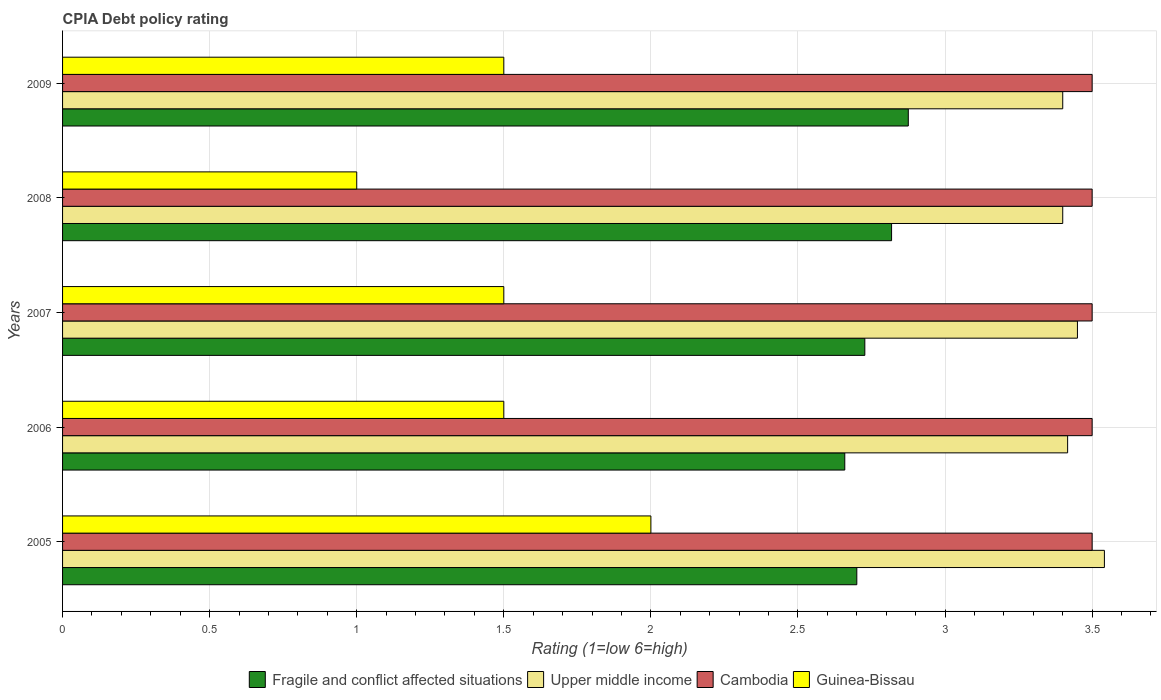How many groups of bars are there?
Offer a terse response. 5. Are the number of bars on each tick of the Y-axis equal?
Your answer should be very brief. Yes. What is the CPIA rating in Upper middle income in 2007?
Ensure brevity in your answer.  3.45. Across all years, what is the maximum CPIA rating in Cambodia?
Make the answer very short. 3.5. Across all years, what is the minimum CPIA rating in Cambodia?
Give a very brief answer. 3.5. In which year was the CPIA rating in Guinea-Bissau minimum?
Keep it short and to the point. 2008. What is the total CPIA rating in Guinea-Bissau in the graph?
Make the answer very short. 7.5. What is the difference between the CPIA rating in Cambodia in 2006 and that in 2007?
Ensure brevity in your answer.  0. What is the difference between the CPIA rating in Fragile and conflict affected situations in 2009 and the CPIA rating in Cambodia in 2008?
Your answer should be compact. -0.62. What is the average CPIA rating in Fragile and conflict affected situations per year?
Ensure brevity in your answer.  2.76. In the year 2005, what is the difference between the CPIA rating in Upper middle income and CPIA rating in Fragile and conflict affected situations?
Give a very brief answer. 0.84. What is the ratio of the CPIA rating in Upper middle income in 2006 to that in 2007?
Offer a very short reply. 0.99. Is the CPIA rating in Guinea-Bissau in 2005 less than that in 2007?
Your response must be concise. No. What is the difference between the highest and the second highest CPIA rating in Upper middle income?
Provide a succinct answer. 0.09. What is the difference between the highest and the lowest CPIA rating in Cambodia?
Provide a short and direct response. 0. In how many years, is the CPIA rating in Cambodia greater than the average CPIA rating in Cambodia taken over all years?
Your response must be concise. 0. Is it the case that in every year, the sum of the CPIA rating in Guinea-Bissau and CPIA rating in Upper middle income is greater than the sum of CPIA rating in Fragile and conflict affected situations and CPIA rating in Cambodia?
Keep it short and to the point. No. What does the 1st bar from the top in 2006 represents?
Your response must be concise. Guinea-Bissau. What does the 3rd bar from the bottom in 2008 represents?
Make the answer very short. Cambodia. Is it the case that in every year, the sum of the CPIA rating in Cambodia and CPIA rating in Guinea-Bissau is greater than the CPIA rating in Fragile and conflict affected situations?
Your answer should be very brief. Yes. How many bars are there?
Your answer should be very brief. 20. Does the graph contain any zero values?
Provide a short and direct response. No. Does the graph contain grids?
Keep it short and to the point. Yes. Where does the legend appear in the graph?
Your answer should be very brief. Bottom center. What is the title of the graph?
Provide a succinct answer. CPIA Debt policy rating. What is the label or title of the X-axis?
Your response must be concise. Rating (1=low 6=high). What is the label or title of the Y-axis?
Provide a short and direct response. Years. What is the Rating (1=low 6=high) in Upper middle income in 2005?
Offer a terse response. 3.54. What is the Rating (1=low 6=high) of Fragile and conflict affected situations in 2006?
Provide a short and direct response. 2.66. What is the Rating (1=low 6=high) in Upper middle income in 2006?
Offer a very short reply. 3.42. What is the Rating (1=low 6=high) of Guinea-Bissau in 2006?
Your answer should be very brief. 1.5. What is the Rating (1=low 6=high) of Fragile and conflict affected situations in 2007?
Your response must be concise. 2.73. What is the Rating (1=low 6=high) of Upper middle income in 2007?
Keep it short and to the point. 3.45. What is the Rating (1=low 6=high) of Cambodia in 2007?
Ensure brevity in your answer.  3.5. What is the Rating (1=low 6=high) of Fragile and conflict affected situations in 2008?
Ensure brevity in your answer.  2.82. What is the Rating (1=low 6=high) in Upper middle income in 2008?
Your answer should be very brief. 3.4. What is the Rating (1=low 6=high) in Cambodia in 2008?
Your response must be concise. 3.5. What is the Rating (1=low 6=high) of Fragile and conflict affected situations in 2009?
Offer a very short reply. 2.88. What is the Rating (1=low 6=high) in Cambodia in 2009?
Provide a succinct answer. 3.5. What is the Rating (1=low 6=high) of Guinea-Bissau in 2009?
Offer a very short reply. 1.5. Across all years, what is the maximum Rating (1=low 6=high) in Fragile and conflict affected situations?
Give a very brief answer. 2.88. Across all years, what is the maximum Rating (1=low 6=high) in Upper middle income?
Provide a succinct answer. 3.54. Across all years, what is the maximum Rating (1=low 6=high) of Guinea-Bissau?
Your response must be concise. 2. Across all years, what is the minimum Rating (1=low 6=high) of Fragile and conflict affected situations?
Make the answer very short. 2.66. Across all years, what is the minimum Rating (1=low 6=high) in Upper middle income?
Offer a very short reply. 3.4. What is the total Rating (1=low 6=high) of Fragile and conflict affected situations in the graph?
Your answer should be very brief. 13.78. What is the total Rating (1=low 6=high) of Upper middle income in the graph?
Offer a very short reply. 17.21. What is the total Rating (1=low 6=high) in Guinea-Bissau in the graph?
Provide a succinct answer. 7.5. What is the difference between the Rating (1=low 6=high) in Fragile and conflict affected situations in 2005 and that in 2006?
Offer a very short reply. 0.04. What is the difference between the Rating (1=low 6=high) of Upper middle income in 2005 and that in 2006?
Keep it short and to the point. 0.12. What is the difference between the Rating (1=low 6=high) of Guinea-Bissau in 2005 and that in 2006?
Provide a succinct answer. 0.5. What is the difference between the Rating (1=low 6=high) of Fragile and conflict affected situations in 2005 and that in 2007?
Provide a short and direct response. -0.03. What is the difference between the Rating (1=low 6=high) of Upper middle income in 2005 and that in 2007?
Make the answer very short. 0.09. What is the difference between the Rating (1=low 6=high) in Guinea-Bissau in 2005 and that in 2007?
Make the answer very short. 0.5. What is the difference between the Rating (1=low 6=high) in Fragile and conflict affected situations in 2005 and that in 2008?
Offer a terse response. -0.12. What is the difference between the Rating (1=low 6=high) in Upper middle income in 2005 and that in 2008?
Your response must be concise. 0.14. What is the difference between the Rating (1=low 6=high) in Cambodia in 2005 and that in 2008?
Keep it short and to the point. 0. What is the difference between the Rating (1=low 6=high) in Fragile and conflict affected situations in 2005 and that in 2009?
Offer a very short reply. -0.17. What is the difference between the Rating (1=low 6=high) in Upper middle income in 2005 and that in 2009?
Offer a terse response. 0.14. What is the difference between the Rating (1=low 6=high) of Fragile and conflict affected situations in 2006 and that in 2007?
Give a very brief answer. -0.07. What is the difference between the Rating (1=low 6=high) in Upper middle income in 2006 and that in 2007?
Your response must be concise. -0.03. What is the difference between the Rating (1=low 6=high) of Guinea-Bissau in 2006 and that in 2007?
Make the answer very short. 0. What is the difference between the Rating (1=low 6=high) of Fragile and conflict affected situations in 2006 and that in 2008?
Your answer should be very brief. -0.16. What is the difference between the Rating (1=low 6=high) of Upper middle income in 2006 and that in 2008?
Offer a terse response. 0.02. What is the difference between the Rating (1=low 6=high) of Guinea-Bissau in 2006 and that in 2008?
Your response must be concise. 0.5. What is the difference between the Rating (1=low 6=high) in Fragile and conflict affected situations in 2006 and that in 2009?
Provide a succinct answer. -0.22. What is the difference between the Rating (1=low 6=high) in Upper middle income in 2006 and that in 2009?
Provide a short and direct response. 0.02. What is the difference between the Rating (1=low 6=high) in Cambodia in 2006 and that in 2009?
Offer a very short reply. 0. What is the difference between the Rating (1=low 6=high) in Guinea-Bissau in 2006 and that in 2009?
Offer a very short reply. 0. What is the difference between the Rating (1=low 6=high) in Fragile and conflict affected situations in 2007 and that in 2008?
Offer a very short reply. -0.09. What is the difference between the Rating (1=low 6=high) in Upper middle income in 2007 and that in 2008?
Your answer should be compact. 0.05. What is the difference between the Rating (1=low 6=high) of Fragile and conflict affected situations in 2007 and that in 2009?
Give a very brief answer. -0.15. What is the difference between the Rating (1=low 6=high) of Cambodia in 2007 and that in 2009?
Your response must be concise. 0. What is the difference between the Rating (1=low 6=high) in Fragile and conflict affected situations in 2008 and that in 2009?
Offer a terse response. -0.06. What is the difference between the Rating (1=low 6=high) of Upper middle income in 2008 and that in 2009?
Provide a short and direct response. 0. What is the difference between the Rating (1=low 6=high) in Fragile and conflict affected situations in 2005 and the Rating (1=low 6=high) in Upper middle income in 2006?
Keep it short and to the point. -0.72. What is the difference between the Rating (1=low 6=high) of Fragile and conflict affected situations in 2005 and the Rating (1=low 6=high) of Cambodia in 2006?
Provide a short and direct response. -0.8. What is the difference between the Rating (1=low 6=high) of Fragile and conflict affected situations in 2005 and the Rating (1=low 6=high) of Guinea-Bissau in 2006?
Keep it short and to the point. 1.2. What is the difference between the Rating (1=low 6=high) in Upper middle income in 2005 and the Rating (1=low 6=high) in Cambodia in 2006?
Your answer should be very brief. 0.04. What is the difference between the Rating (1=low 6=high) of Upper middle income in 2005 and the Rating (1=low 6=high) of Guinea-Bissau in 2006?
Provide a succinct answer. 2.04. What is the difference between the Rating (1=low 6=high) in Fragile and conflict affected situations in 2005 and the Rating (1=low 6=high) in Upper middle income in 2007?
Offer a very short reply. -0.75. What is the difference between the Rating (1=low 6=high) of Fragile and conflict affected situations in 2005 and the Rating (1=low 6=high) of Cambodia in 2007?
Your answer should be compact. -0.8. What is the difference between the Rating (1=low 6=high) in Fragile and conflict affected situations in 2005 and the Rating (1=low 6=high) in Guinea-Bissau in 2007?
Offer a terse response. 1.2. What is the difference between the Rating (1=low 6=high) in Upper middle income in 2005 and the Rating (1=low 6=high) in Cambodia in 2007?
Provide a short and direct response. 0.04. What is the difference between the Rating (1=low 6=high) of Upper middle income in 2005 and the Rating (1=low 6=high) of Guinea-Bissau in 2007?
Keep it short and to the point. 2.04. What is the difference between the Rating (1=low 6=high) of Fragile and conflict affected situations in 2005 and the Rating (1=low 6=high) of Upper middle income in 2008?
Keep it short and to the point. -0.7. What is the difference between the Rating (1=low 6=high) of Upper middle income in 2005 and the Rating (1=low 6=high) of Cambodia in 2008?
Provide a succinct answer. 0.04. What is the difference between the Rating (1=low 6=high) in Upper middle income in 2005 and the Rating (1=low 6=high) in Guinea-Bissau in 2008?
Keep it short and to the point. 2.54. What is the difference between the Rating (1=low 6=high) of Fragile and conflict affected situations in 2005 and the Rating (1=low 6=high) of Cambodia in 2009?
Your answer should be very brief. -0.8. What is the difference between the Rating (1=low 6=high) in Upper middle income in 2005 and the Rating (1=low 6=high) in Cambodia in 2009?
Your answer should be very brief. 0.04. What is the difference between the Rating (1=low 6=high) in Upper middle income in 2005 and the Rating (1=low 6=high) in Guinea-Bissau in 2009?
Ensure brevity in your answer.  2.04. What is the difference between the Rating (1=low 6=high) in Cambodia in 2005 and the Rating (1=low 6=high) in Guinea-Bissau in 2009?
Offer a terse response. 2. What is the difference between the Rating (1=low 6=high) in Fragile and conflict affected situations in 2006 and the Rating (1=low 6=high) in Upper middle income in 2007?
Provide a short and direct response. -0.79. What is the difference between the Rating (1=low 6=high) in Fragile and conflict affected situations in 2006 and the Rating (1=low 6=high) in Cambodia in 2007?
Offer a terse response. -0.84. What is the difference between the Rating (1=low 6=high) in Fragile and conflict affected situations in 2006 and the Rating (1=low 6=high) in Guinea-Bissau in 2007?
Your answer should be compact. 1.16. What is the difference between the Rating (1=low 6=high) of Upper middle income in 2006 and the Rating (1=low 6=high) of Cambodia in 2007?
Your response must be concise. -0.08. What is the difference between the Rating (1=low 6=high) of Upper middle income in 2006 and the Rating (1=low 6=high) of Guinea-Bissau in 2007?
Make the answer very short. 1.92. What is the difference between the Rating (1=low 6=high) in Fragile and conflict affected situations in 2006 and the Rating (1=low 6=high) in Upper middle income in 2008?
Your response must be concise. -0.74. What is the difference between the Rating (1=low 6=high) in Fragile and conflict affected situations in 2006 and the Rating (1=low 6=high) in Cambodia in 2008?
Keep it short and to the point. -0.84. What is the difference between the Rating (1=low 6=high) of Fragile and conflict affected situations in 2006 and the Rating (1=low 6=high) of Guinea-Bissau in 2008?
Keep it short and to the point. 1.66. What is the difference between the Rating (1=low 6=high) of Upper middle income in 2006 and the Rating (1=low 6=high) of Cambodia in 2008?
Keep it short and to the point. -0.08. What is the difference between the Rating (1=low 6=high) of Upper middle income in 2006 and the Rating (1=low 6=high) of Guinea-Bissau in 2008?
Ensure brevity in your answer.  2.42. What is the difference between the Rating (1=low 6=high) of Cambodia in 2006 and the Rating (1=low 6=high) of Guinea-Bissau in 2008?
Provide a succinct answer. 2.5. What is the difference between the Rating (1=low 6=high) in Fragile and conflict affected situations in 2006 and the Rating (1=low 6=high) in Upper middle income in 2009?
Your answer should be very brief. -0.74. What is the difference between the Rating (1=low 6=high) of Fragile and conflict affected situations in 2006 and the Rating (1=low 6=high) of Cambodia in 2009?
Your answer should be compact. -0.84. What is the difference between the Rating (1=low 6=high) in Fragile and conflict affected situations in 2006 and the Rating (1=low 6=high) in Guinea-Bissau in 2009?
Give a very brief answer. 1.16. What is the difference between the Rating (1=low 6=high) in Upper middle income in 2006 and the Rating (1=low 6=high) in Cambodia in 2009?
Make the answer very short. -0.08. What is the difference between the Rating (1=low 6=high) of Upper middle income in 2006 and the Rating (1=low 6=high) of Guinea-Bissau in 2009?
Give a very brief answer. 1.92. What is the difference between the Rating (1=low 6=high) of Fragile and conflict affected situations in 2007 and the Rating (1=low 6=high) of Upper middle income in 2008?
Your answer should be compact. -0.67. What is the difference between the Rating (1=low 6=high) in Fragile and conflict affected situations in 2007 and the Rating (1=low 6=high) in Cambodia in 2008?
Provide a short and direct response. -0.77. What is the difference between the Rating (1=low 6=high) of Fragile and conflict affected situations in 2007 and the Rating (1=low 6=high) of Guinea-Bissau in 2008?
Provide a succinct answer. 1.73. What is the difference between the Rating (1=low 6=high) in Upper middle income in 2007 and the Rating (1=low 6=high) in Cambodia in 2008?
Offer a very short reply. -0.05. What is the difference between the Rating (1=low 6=high) of Upper middle income in 2007 and the Rating (1=low 6=high) of Guinea-Bissau in 2008?
Ensure brevity in your answer.  2.45. What is the difference between the Rating (1=low 6=high) in Cambodia in 2007 and the Rating (1=low 6=high) in Guinea-Bissau in 2008?
Keep it short and to the point. 2.5. What is the difference between the Rating (1=low 6=high) of Fragile and conflict affected situations in 2007 and the Rating (1=low 6=high) of Upper middle income in 2009?
Offer a terse response. -0.67. What is the difference between the Rating (1=low 6=high) of Fragile and conflict affected situations in 2007 and the Rating (1=low 6=high) of Cambodia in 2009?
Offer a terse response. -0.77. What is the difference between the Rating (1=low 6=high) in Fragile and conflict affected situations in 2007 and the Rating (1=low 6=high) in Guinea-Bissau in 2009?
Ensure brevity in your answer.  1.23. What is the difference between the Rating (1=low 6=high) of Upper middle income in 2007 and the Rating (1=low 6=high) of Guinea-Bissau in 2009?
Your answer should be compact. 1.95. What is the difference between the Rating (1=low 6=high) of Fragile and conflict affected situations in 2008 and the Rating (1=low 6=high) of Upper middle income in 2009?
Your answer should be very brief. -0.58. What is the difference between the Rating (1=low 6=high) of Fragile and conflict affected situations in 2008 and the Rating (1=low 6=high) of Cambodia in 2009?
Your response must be concise. -0.68. What is the difference between the Rating (1=low 6=high) of Fragile and conflict affected situations in 2008 and the Rating (1=low 6=high) of Guinea-Bissau in 2009?
Provide a short and direct response. 1.32. What is the difference between the Rating (1=low 6=high) of Cambodia in 2008 and the Rating (1=low 6=high) of Guinea-Bissau in 2009?
Provide a succinct answer. 2. What is the average Rating (1=low 6=high) in Fragile and conflict affected situations per year?
Keep it short and to the point. 2.76. What is the average Rating (1=low 6=high) in Upper middle income per year?
Offer a terse response. 3.44. What is the average Rating (1=low 6=high) in Cambodia per year?
Offer a very short reply. 3.5. What is the average Rating (1=low 6=high) in Guinea-Bissau per year?
Make the answer very short. 1.5. In the year 2005, what is the difference between the Rating (1=low 6=high) of Fragile and conflict affected situations and Rating (1=low 6=high) of Upper middle income?
Ensure brevity in your answer.  -0.84. In the year 2005, what is the difference between the Rating (1=low 6=high) in Fragile and conflict affected situations and Rating (1=low 6=high) in Cambodia?
Give a very brief answer. -0.8. In the year 2005, what is the difference between the Rating (1=low 6=high) in Fragile and conflict affected situations and Rating (1=low 6=high) in Guinea-Bissau?
Offer a very short reply. 0.7. In the year 2005, what is the difference between the Rating (1=low 6=high) in Upper middle income and Rating (1=low 6=high) in Cambodia?
Ensure brevity in your answer.  0.04. In the year 2005, what is the difference between the Rating (1=low 6=high) in Upper middle income and Rating (1=low 6=high) in Guinea-Bissau?
Your response must be concise. 1.54. In the year 2005, what is the difference between the Rating (1=low 6=high) of Cambodia and Rating (1=low 6=high) of Guinea-Bissau?
Your answer should be compact. 1.5. In the year 2006, what is the difference between the Rating (1=low 6=high) of Fragile and conflict affected situations and Rating (1=low 6=high) of Upper middle income?
Keep it short and to the point. -0.76. In the year 2006, what is the difference between the Rating (1=low 6=high) in Fragile and conflict affected situations and Rating (1=low 6=high) in Cambodia?
Provide a succinct answer. -0.84. In the year 2006, what is the difference between the Rating (1=low 6=high) in Fragile and conflict affected situations and Rating (1=low 6=high) in Guinea-Bissau?
Offer a terse response. 1.16. In the year 2006, what is the difference between the Rating (1=low 6=high) in Upper middle income and Rating (1=low 6=high) in Cambodia?
Your answer should be very brief. -0.08. In the year 2006, what is the difference between the Rating (1=low 6=high) of Upper middle income and Rating (1=low 6=high) of Guinea-Bissau?
Provide a short and direct response. 1.92. In the year 2006, what is the difference between the Rating (1=low 6=high) of Cambodia and Rating (1=low 6=high) of Guinea-Bissau?
Offer a very short reply. 2. In the year 2007, what is the difference between the Rating (1=low 6=high) in Fragile and conflict affected situations and Rating (1=low 6=high) in Upper middle income?
Provide a succinct answer. -0.72. In the year 2007, what is the difference between the Rating (1=low 6=high) of Fragile and conflict affected situations and Rating (1=low 6=high) of Cambodia?
Your answer should be compact. -0.77. In the year 2007, what is the difference between the Rating (1=low 6=high) of Fragile and conflict affected situations and Rating (1=low 6=high) of Guinea-Bissau?
Provide a short and direct response. 1.23. In the year 2007, what is the difference between the Rating (1=low 6=high) of Upper middle income and Rating (1=low 6=high) of Cambodia?
Make the answer very short. -0.05. In the year 2007, what is the difference between the Rating (1=low 6=high) in Upper middle income and Rating (1=low 6=high) in Guinea-Bissau?
Provide a short and direct response. 1.95. In the year 2007, what is the difference between the Rating (1=low 6=high) of Cambodia and Rating (1=low 6=high) of Guinea-Bissau?
Ensure brevity in your answer.  2. In the year 2008, what is the difference between the Rating (1=low 6=high) of Fragile and conflict affected situations and Rating (1=low 6=high) of Upper middle income?
Your response must be concise. -0.58. In the year 2008, what is the difference between the Rating (1=low 6=high) in Fragile and conflict affected situations and Rating (1=low 6=high) in Cambodia?
Provide a short and direct response. -0.68. In the year 2008, what is the difference between the Rating (1=low 6=high) in Fragile and conflict affected situations and Rating (1=low 6=high) in Guinea-Bissau?
Provide a short and direct response. 1.82. In the year 2008, what is the difference between the Rating (1=low 6=high) of Upper middle income and Rating (1=low 6=high) of Cambodia?
Provide a succinct answer. -0.1. In the year 2008, what is the difference between the Rating (1=low 6=high) of Upper middle income and Rating (1=low 6=high) of Guinea-Bissau?
Ensure brevity in your answer.  2.4. In the year 2008, what is the difference between the Rating (1=low 6=high) in Cambodia and Rating (1=low 6=high) in Guinea-Bissau?
Your answer should be very brief. 2.5. In the year 2009, what is the difference between the Rating (1=low 6=high) of Fragile and conflict affected situations and Rating (1=low 6=high) of Upper middle income?
Offer a very short reply. -0.53. In the year 2009, what is the difference between the Rating (1=low 6=high) in Fragile and conflict affected situations and Rating (1=low 6=high) in Cambodia?
Offer a very short reply. -0.62. In the year 2009, what is the difference between the Rating (1=low 6=high) in Fragile and conflict affected situations and Rating (1=low 6=high) in Guinea-Bissau?
Your answer should be compact. 1.38. In the year 2009, what is the difference between the Rating (1=low 6=high) in Cambodia and Rating (1=low 6=high) in Guinea-Bissau?
Your answer should be compact. 2. What is the ratio of the Rating (1=low 6=high) of Fragile and conflict affected situations in 2005 to that in 2006?
Your response must be concise. 1.02. What is the ratio of the Rating (1=low 6=high) of Upper middle income in 2005 to that in 2006?
Offer a very short reply. 1.04. What is the ratio of the Rating (1=low 6=high) in Cambodia in 2005 to that in 2006?
Ensure brevity in your answer.  1. What is the ratio of the Rating (1=low 6=high) in Guinea-Bissau in 2005 to that in 2006?
Your response must be concise. 1.33. What is the ratio of the Rating (1=low 6=high) of Fragile and conflict affected situations in 2005 to that in 2007?
Make the answer very short. 0.99. What is the ratio of the Rating (1=low 6=high) in Upper middle income in 2005 to that in 2007?
Your response must be concise. 1.03. What is the ratio of the Rating (1=low 6=high) in Cambodia in 2005 to that in 2007?
Your answer should be compact. 1. What is the ratio of the Rating (1=low 6=high) of Guinea-Bissau in 2005 to that in 2007?
Your answer should be very brief. 1.33. What is the ratio of the Rating (1=low 6=high) of Fragile and conflict affected situations in 2005 to that in 2008?
Offer a very short reply. 0.96. What is the ratio of the Rating (1=low 6=high) of Upper middle income in 2005 to that in 2008?
Provide a short and direct response. 1.04. What is the ratio of the Rating (1=low 6=high) in Cambodia in 2005 to that in 2008?
Your answer should be compact. 1. What is the ratio of the Rating (1=low 6=high) in Fragile and conflict affected situations in 2005 to that in 2009?
Your answer should be compact. 0.94. What is the ratio of the Rating (1=low 6=high) of Upper middle income in 2005 to that in 2009?
Make the answer very short. 1.04. What is the ratio of the Rating (1=low 6=high) in Cambodia in 2005 to that in 2009?
Give a very brief answer. 1. What is the ratio of the Rating (1=low 6=high) of Fragile and conflict affected situations in 2006 to that in 2007?
Offer a terse response. 0.97. What is the ratio of the Rating (1=low 6=high) in Upper middle income in 2006 to that in 2007?
Provide a short and direct response. 0.99. What is the ratio of the Rating (1=low 6=high) of Cambodia in 2006 to that in 2007?
Make the answer very short. 1. What is the ratio of the Rating (1=low 6=high) of Guinea-Bissau in 2006 to that in 2007?
Keep it short and to the point. 1. What is the ratio of the Rating (1=low 6=high) of Fragile and conflict affected situations in 2006 to that in 2008?
Provide a short and direct response. 0.94. What is the ratio of the Rating (1=low 6=high) in Cambodia in 2006 to that in 2008?
Offer a terse response. 1. What is the ratio of the Rating (1=low 6=high) of Guinea-Bissau in 2006 to that in 2008?
Ensure brevity in your answer.  1.5. What is the ratio of the Rating (1=low 6=high) in Fragile and conflict affected situations in 2006 to that in 2009?
Your answer should be very brief. 0.92. What is the ratio of the Rating (1=low 6=high) of Upper middle income in 2006 to that in 2009?
Ensure brevity in your answer.  1. What is the ratio of the Rating (1=low 6=high) in Cambodia in 2006 to that in 2009?
Your answer should be compact. 1. What is the ratio of the Rating (1=low 6=high) in Upper middle income in 2007 to that in 2008?
Your answer should be very brief. 1.01. What is the ratio of the Rating (1=low 6=high) in Fragile and conflict affected situations in 2007 to that in 2009?
Your response must be concise. 0.95. What is the ratio of the Rating (1=low 6=high) of Upper middle income in 2007 to that in 2009?
Offer a terse response. 1.01. What is the ratio of the Rating (1=low 6=high) of Fragile and conflict affected situations in 2008 to that in 2009?
Provide a short and direct response. 0.98. What is the ratio of the Rating (1=low 6=high) in Upper middle income in 2008 to that in 2009?
Your answer should be very brief. 1. What is the ratio of the Rating (1=low 6=high) in Guinea-Bissau in 2008 to that in 2009?
Give a very brief answer. 0.67. What is the difference between the highest and the second highest Rating (1=low 6=high) in Fragile and conflict affected situations?
Make the answer very short. 0.06. What is the difference between the highest and the second highest Rating (1=low 6=high) of Upper middle income?
Provide a short and direct response. 0.09. What is the difference between the highest and the second highest Rating (1=low 6=high) in Cambodia?
Provide a short and direct response. 0. What is the difference between the highest and the second highest Rating (1=low 6=high) of Guinea-Bissau?
Give a very brief answer. 0.5. What is the difference between the highest and the lowest Rating (1=low 6=high) in Fragile and conflict affected situations?
Give a very brief answer. 0.22. What is the difference between the highest and the lowest Rating (1=low 6=high) in Upper middle income?
Give a very brief answer. 0.14. What is the difference between the highest and the lowest Rating (1=low 6=high) of Cambodia?
Provide a succinct answer. 0. 